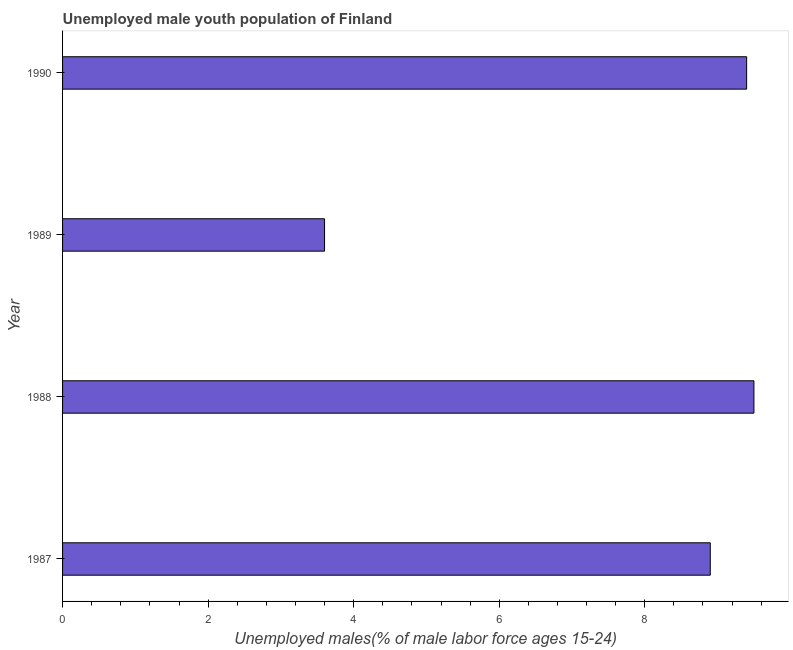Does the graph contain grids?
Your answer should be very brief. No. What is the title of the graph?
Your answer should be very brief. Unemployed male youth population of Finland. What is the label or title of the X-axis?
Make the answer very short. Unemployed males(% of male labor force ages 15-24). What is the unemployed male youth in 1989?
Provide a short and direct response. 3.6. Across all years, what is the maximum unemployed male youth?
Your answer should be compact. 9.5. Across all years, what is the minimum unemployed male youth?
Your answer should be very brief. 3.6. In which year was the unemployed male youth maximum?
Your response must be concise. 1988. What is the sum of the unemployed male youth?
Your response must be concise. 31.4. What is the average unemployed male youth per year?
Your answer should be compact. 7.85. What is the median unemployed male youth?
Keep it short and to the point. 9.15. What is the ratio of the unemployed male youth in 1987 to that in 1990?
Give a very brief answer. 0.95. Is the unemployed male youth in 1987 less than that in 1988?
Keep it short and to the point. Yes. Is the difference between the unemployed male youth in 1987 and 1989 greater than the difference between any two years?
Offer a terse response. No. What is the difference between the highest and the second highest unemployed male youth?
Provide a short and direct response. 0.1. Is the sum of the unemployed male youth in 1987 and 1990 greater than the maximum unemployed male youth across all years?
Your answer should be very brief. Yes. In how many years, is the unemployed male youth greater than the average unemployed male youth taken over all years?
Give a very brief answer. 3. What is the Unemployed males(% of male labor force ages 15-24) of 1987?
Make the answer very short. 8.9. What is the Unemployed males(% of male labor force ages 15-24) in 1988?
Your answer should be very brief. 9.5. What is the Unemployed males(% of male labor force ages 15-24) of 1989?
Offer a terse response. 3.6. What is the Unemployed males(% of male labor force ages 15-24) of 1990?
Keep it short and to the point. 9.4. What is the difference between the Unemployed males(% of male labor force ages 15-24) in 1987 and 1988?
Keep it short and to the point. -0.6. What is the difference between the Unemployed males(% of male labor force ages 15-24) in 1988 and 1990?
Offer a terse response. 0.1. What is the ratio of the Unemployed males(% of male labor force ages 15-24) in 1987 to that in 1988?
Your answer should be very brief. 0.94. What is the ratio of the Unemployed males(% of male labor force ages 15-24) in 1987 to that in 1989?
Give a very brief answer. 2.47. What is the ratio of the Unemployed males(% of male labor force ages 15-24) in 1987 to that in 1990?
Make the answer very short. 0.95. What is the ratio of the Unemployed males(% of male labor force ages 15-24) in 1988 to that in 1989?
Give a very brief answer. 2.64. What is the ratio of the Unemployed males(% of male labor force ages 15-24) in 1988 to that in 1990?
Make the answer very short. 1.01. What is the ratio of the Unemployed males(% of male labor force ages 15-24) in 1989 to that in 1990?
Provide a succinct answer. 0.38. 